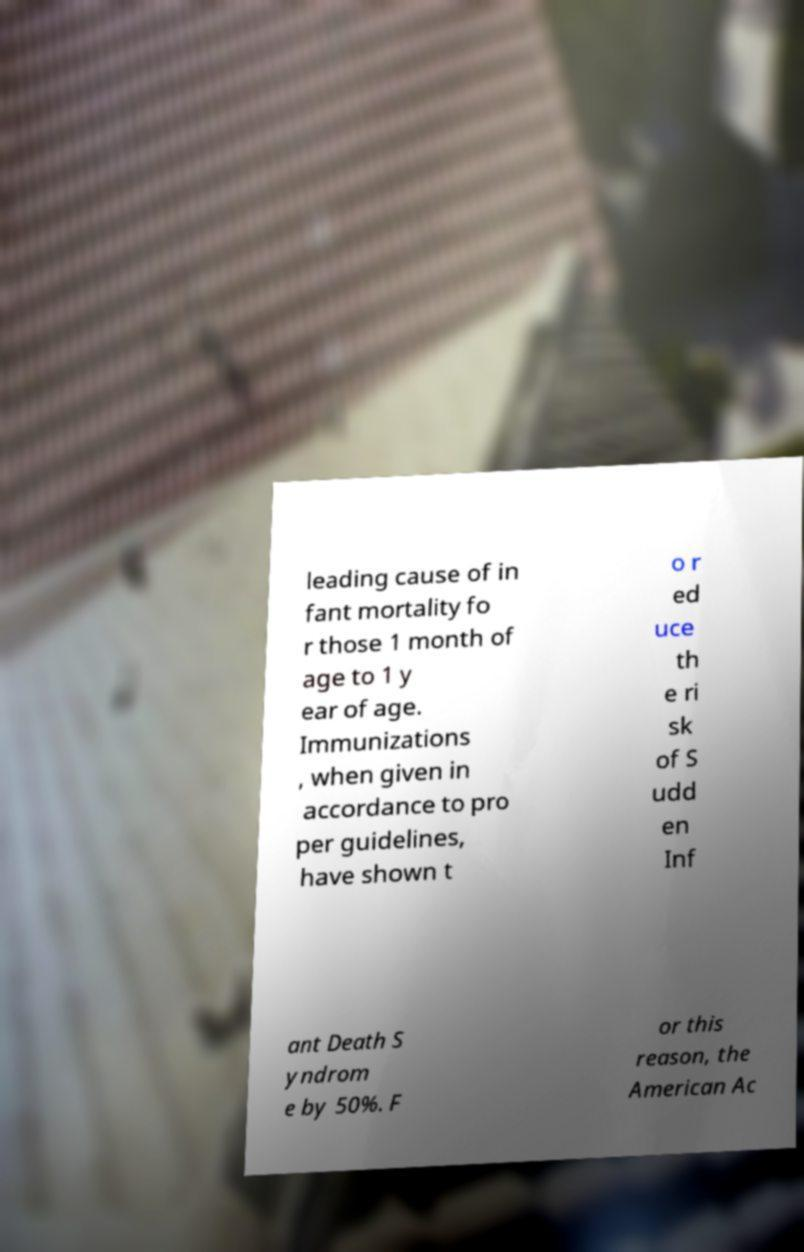I need the written content from this picture converted into text. Can you do that? leading cause of in fant mortality fo r those 1 month of age to 1 y ear of age. Immunizations , when given in accordance to pro per guidelines, have shown t o r ed uce th e ri sk of S udd en Inf ant Death S yndrom e by 50%. F or this reason, the American Ac 